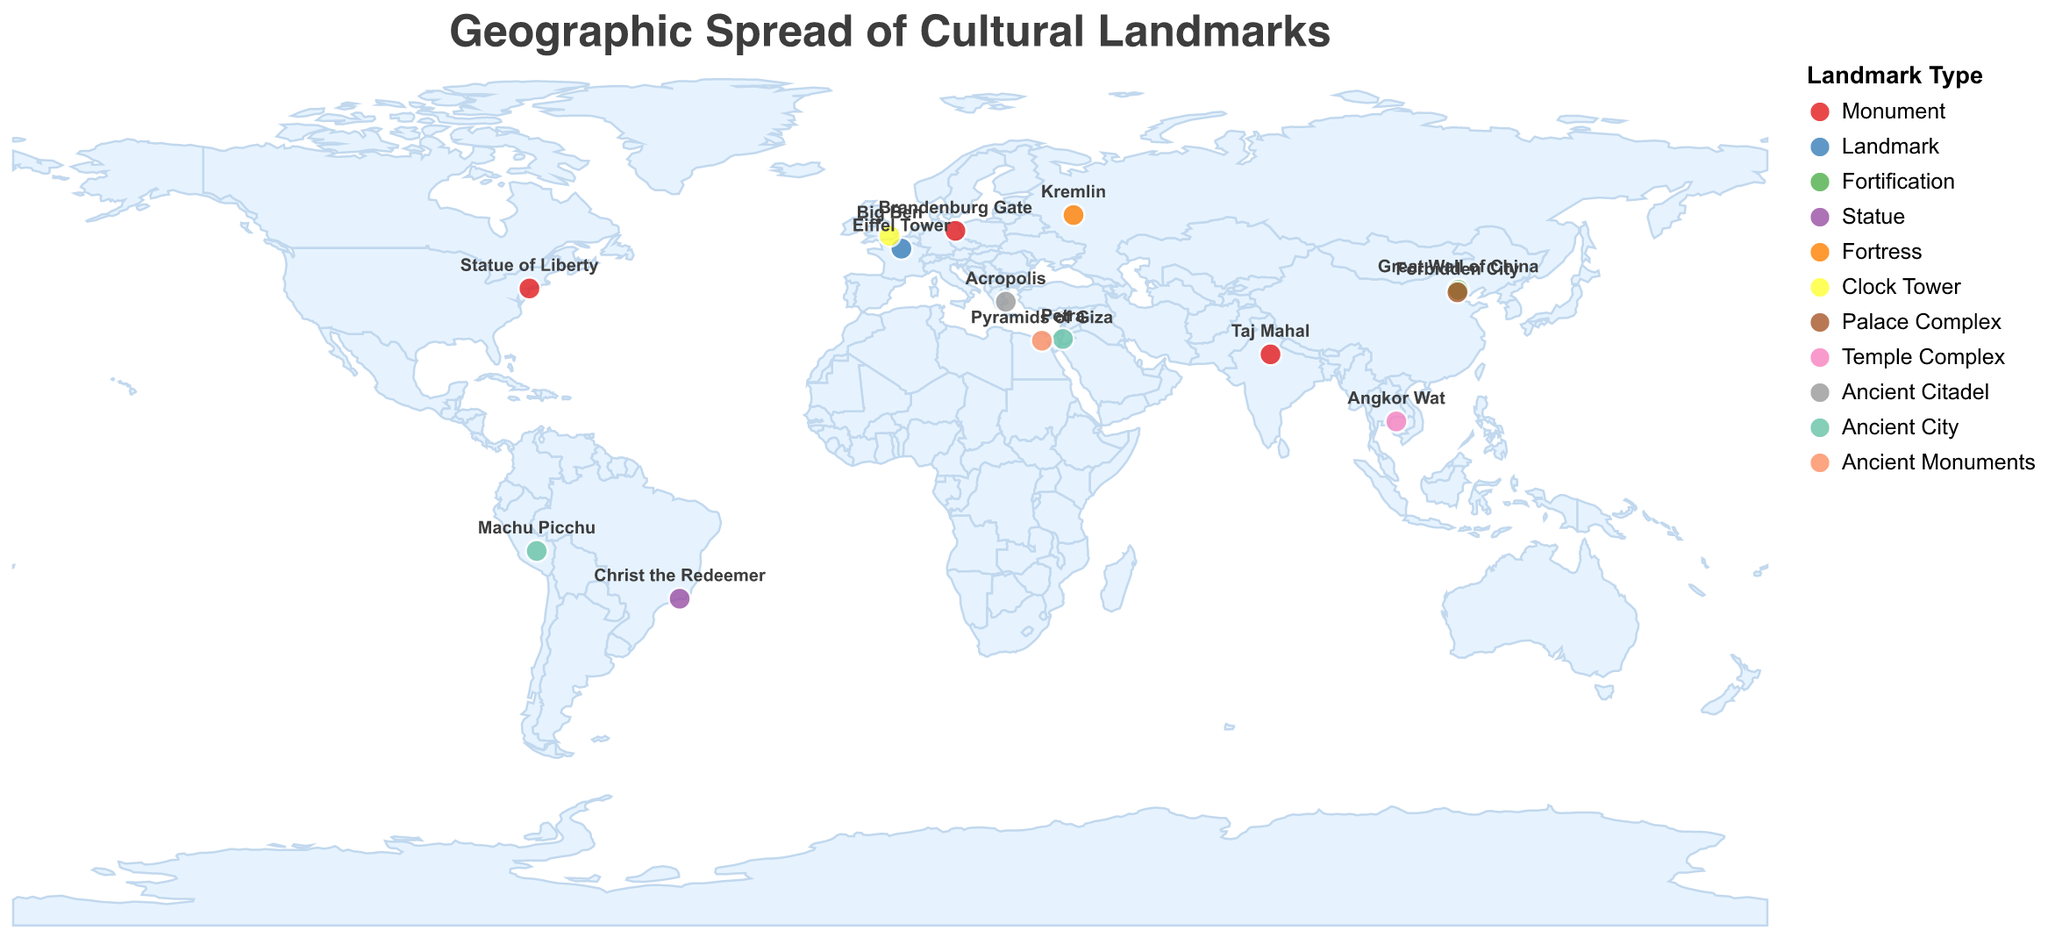What is the title of the plot? The title of the plot is written at the top and usually represents the overall theme or subject of the visualization.
Answer: Geographic Spread of Cultural Landmarks How many types of landmarks are represented in the plot? Look at the legend titled "Landmark Type". Count the different colors/shapes associated with each type.
Answer: 11 Which country has the most cultural landmarks represented in the plot? Identify the countries listed in the tooltips for the various points. Count the entries for each country.
Answer: China What is the significance of the landmark located at latitude 29.9792 and longitude 31.1342? Identify the point on the plot with the specified latitude and longitude. Hover over it to read the tooltip for the significance.
Answer: Symbol of ancient Egyptian civilization and national identity Which landmarks are found in the southern hemisphere? Identify the landmarks with negative latitude values, which indicate locations in the southern hemisphere.
Answer: Christ the Redeemer, Machu Picchu Compare the significance of the landmarks in France and the United States. Hover over the points corresponding to France and the United States to read the tooltip. Summarize the significance of each landmark.
Answer: France's landmark is an icon of French culture and engineering. The United States' landmark is a symbol of freedom and national identity How many landmarks are categorized as monuments? Look at the legend to understand the color representation. Count the points associated with the color for "Monument".
Answer: 3 Which landmark is the furthest east? Identify the landmark with the highest (most positive) longitude value.
Answer: Great Wall of China What is the common characteristic of the landmarks labeled with the color representing "Ancient City"? Refer to the legend to find the color for "Ancient City". Identify the common description or significance from the tooltips.
Answer: They are symbols of ancient civilizations and national heritage Identify one landmark that serves as a national icon as well as representing a religious symbol. Hover over the points to read the tooltips and identify any landmark that fits both descriptions.
Answer: Christ the Redeemer 